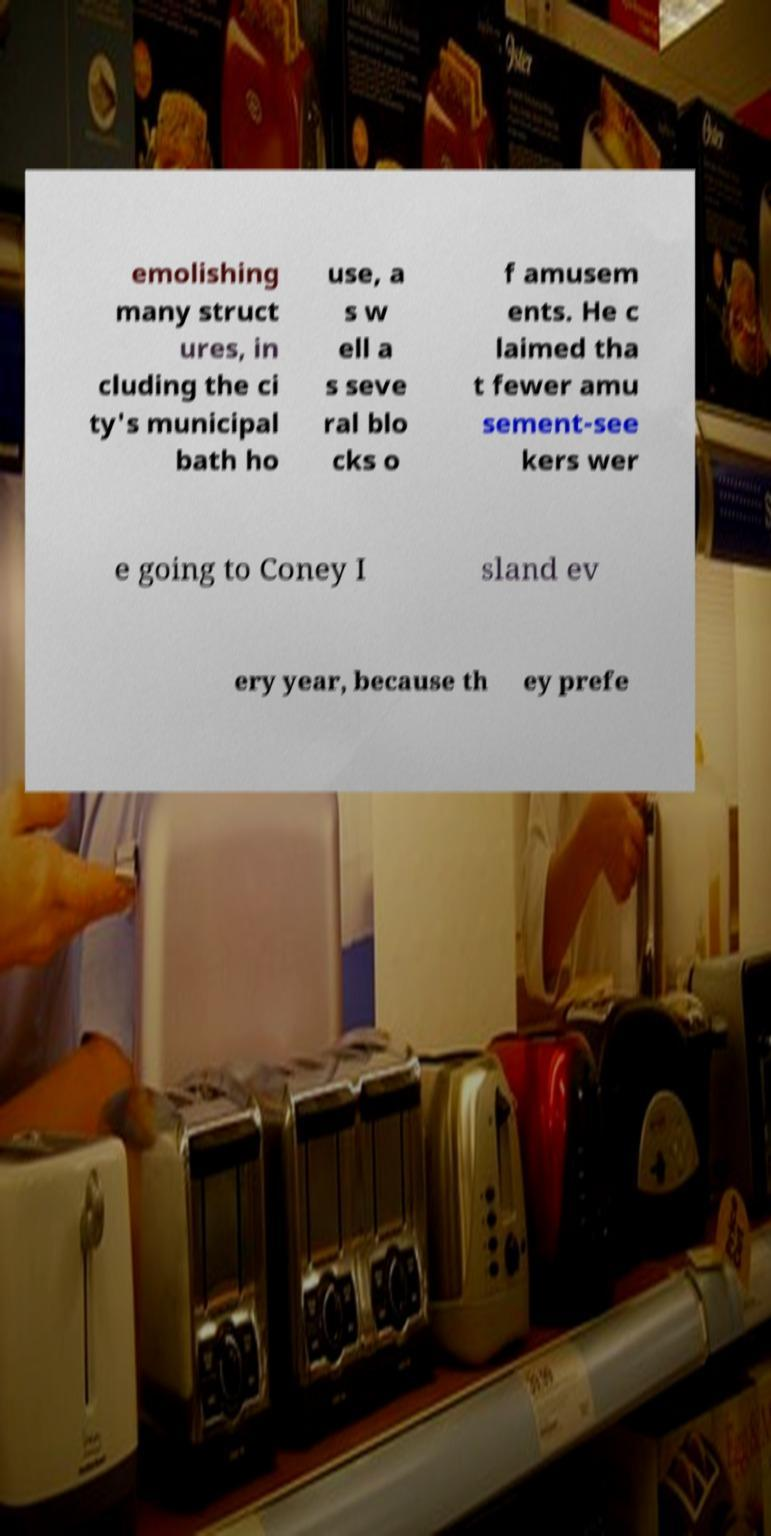What messages or text are displayed in this image? I need them in a readable, typed format. emolishing many struct ures, in cluding the ci ty's municipal bath ho use, a s w ell a s seve ral blo cks o f amusem ents. He c laimed tha t fewer amu sement-see kers wer e going to Coney I sland ev ery year, because th ey prefe 